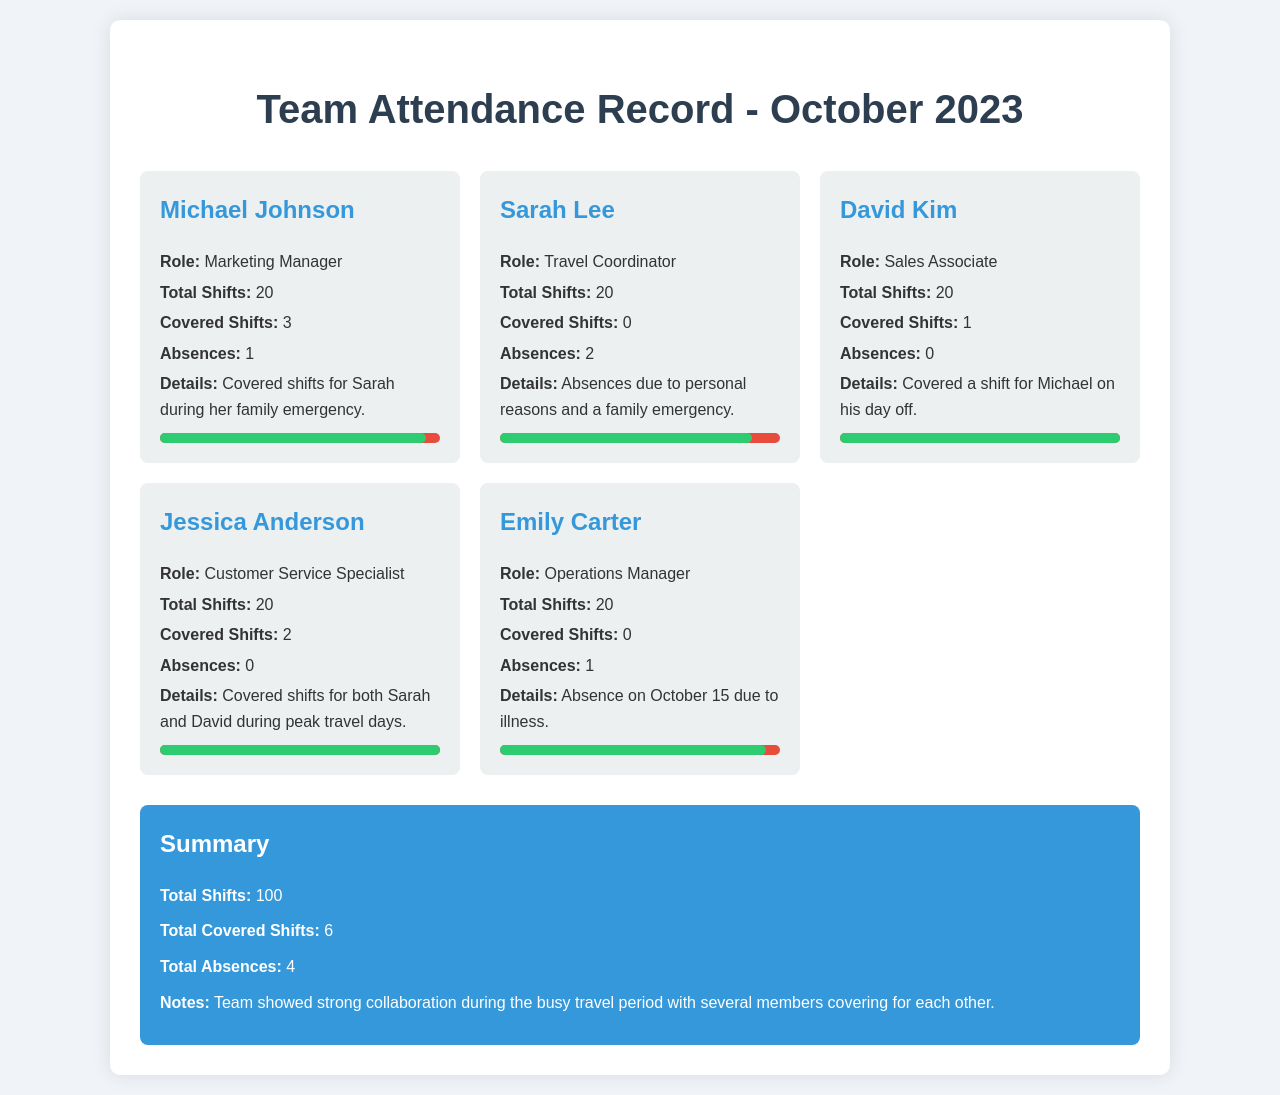What is Michael Johnson's role? Michael Johnson is listed as the Marketing Manager in the document.
Answer: Marketing Manager How many total shifts did Sarah Lee have? The document states that Sarah Lee had a total of 20 shifts.
Answer: 20 Who covered a shift for Michael Johnson? The details in the document mention that David Kim covered a shift for Michael.
Answer: David Kim What was the reason for Emily Carter's absence? The document notes that Emily Carter was absent due to illness on October 15.
Answer: Illness How many total covered shifts are there in the summary? The summary states that there were a total of 6 covered shifts.
Answer: 6 What percentage of shifts did Jessica Anderson cover? Jessica Anderson covered a total of 2 shifts out of her 20, which can be inferred from the information given.
Answer: 2 Which team member had the highest number of absences? The document indicates that Sarah Lee had the highest number of absences with 2.
Answer: Sarah Lee What is the total number of team members in this report? The report includes information on 5 different team members.
Answer: 5 What is the main note in the summary? The summary mentions that the team showed strong collaboration during the busy travel period.
Answer: Strong collaboration 